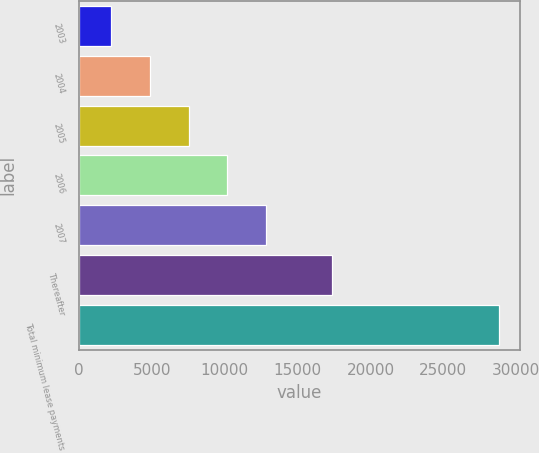Convert chart to OTSL. <chart><loc_0><loc_0><loc_500><loc_500><bar_chart><fcel>2003<fcel>2004<fcel>2005<fcel>2006<fcel>2007<fcel>Thereafter<fcel>Total minimum lease payments<nl><fcel>2195<fcel>4858.3<fcel>7521.6<fcel>10184.9<fcel>12848.2<fcel>17341<fcel>28828<nl></chart> 